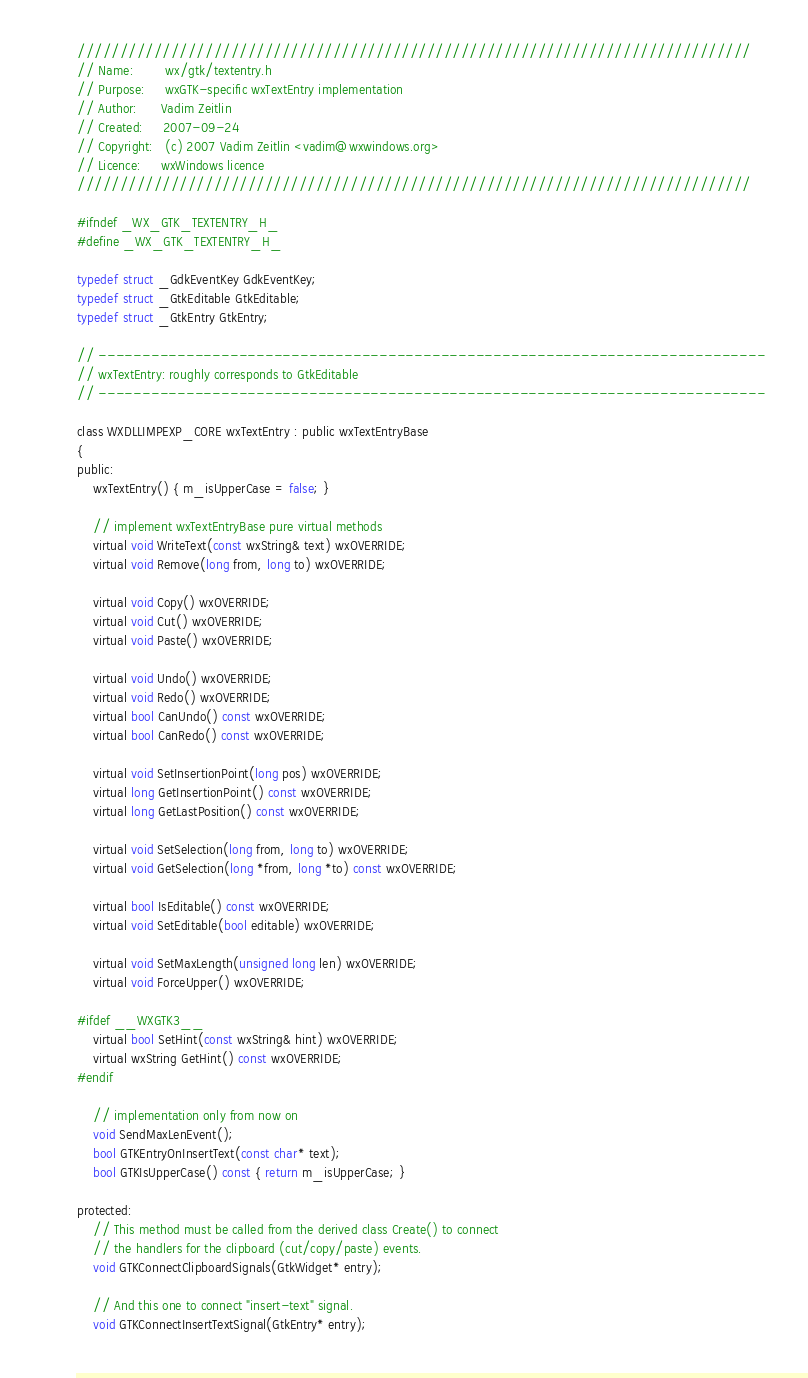<code> <loc_0><loc_0><loc_500><loc_500><_C_>///////////////////////////////////////////////////////////////////////////////
// Name:        wx/gtk/textentry.h
// Purpose:     wxGTK-specific wxTextEntry implementation
// Author:      Vadim Zeitlin
// Created:     2007-09-24
// Copyright:   (c) 2007 Vadim Zeitlin <vadim@wxwindows.org>
// Licence:     wxWindows licence
///////////////////////////////////////////////////////////////////////////////

#ifndef _WX_GTK_TEXTENTRY_H_
#define _WX_GTK_TEXTENTRY_H_

typedef struct _GdkEventKey GdkEventKey;
typedef struct _GtkEditable GtkEditable;
typedef struct _GtkEntry GtkEntry;

// ----------------------------------------------------------------------------
// wxTextEntry: roughly corresponds to GtkEditable
// ----------------------------------------------------------------------------

class WXDLLIMPEXP_CORE wxTextEntry : public wxTextEntryBase
{
public:
    wxTextEntry() { m_isUpperCase = false; }

    // implement wxTextEntryBase pure virtual methods
    virtual void WriteText(const wxString& text) wxOVERRIDE;
    virtual void Remove(long from, long to) wxOVERRIDE;

    virtual void Copy() wxOVERRIDE;
    virtual void Cut() wxOVERRIDE;
    virtual void Paste() wxOVERRIDE;

    virtual void Undo() wxOVERRIDE;
    virtual void Redo() wxOVERRIDE;
    virtual bool CanUndo() const wxOVERRIDE;
    virtual bool CanRedo() const wxOVERRIDE;

    virtual void SetInsertionPoint(long pos) wxOVERRIDE;
    virtual long GetInsertionPoint() const wxOVERRIDE;
    virtual long GetLastPosition() const wxOVERRIDE;

    virtual void SetSelection(long from, long to) wxOVERRIDE;
    virtual void GetSelection(long *from, long *to) const wxOVERRIDE;

    virtual bool IsEditable() const wxOVERRIDE;
    virtual void SetEditable(bool editable) wxOVERRIDE;

    virtual void SetMaxLength(unsigned long len) wxOVERRIDE;
    virtual void ForceUpper() wxOVERRIDE;

#ifdef __WXGTK3__
    virtual bool SetHint(const wxString& hint) wxOVERRIDE;
    virtual wxString GetHint() const wxOVERRIDE;
#endif

    // implementation only from now on
    void SendMaxLenEvent();
    bool GTKEntryOnInsertText(const char* text);
    bool GTKIsUpperCase() const { return m_isUpperCase; }

protected:
    // This method must be called from the derived class Create() to connect
    // the handlers for the clipboard (cut/copy/paste) events.
    void GTKConnectClipboardSignals(GtkWidget* entry);

    // And this one to connect "insert-text" signal.
    void GTKConnectInsertTextSignal(GtkEntry* entry);

</code> 